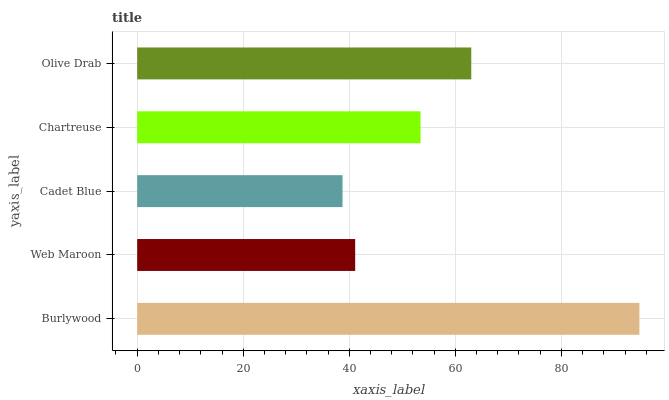Is Cadet Blue the minimum?
Answer yes or no. Yes. Is Burlywood the maximum?
Answer yes or no. Yes. Is Web Maroon the minimum?
Answer yes or no. No. Is Web Maroon the maximum?
Answer yes or no. No. Is Burlywood greater than Web Maroon?
Answer yes or no. Yes. Is Web Maroon less than Burlywood?
Answer yes or no. Yes. Is Web Maroon greater than Burlywood?
Answer yes or no. No. Is Burlywood less than Web Maroon?
Answer yes or no. No. Is Chartreuse the high median?
Answer yes or no. Yes. Is Chartreuse the low median?
Answer yes or no. Yes. Is Olive Drab the high median?
Answer yes or no. No. Is Burlywood the low median?
Answer yes or no. No. 